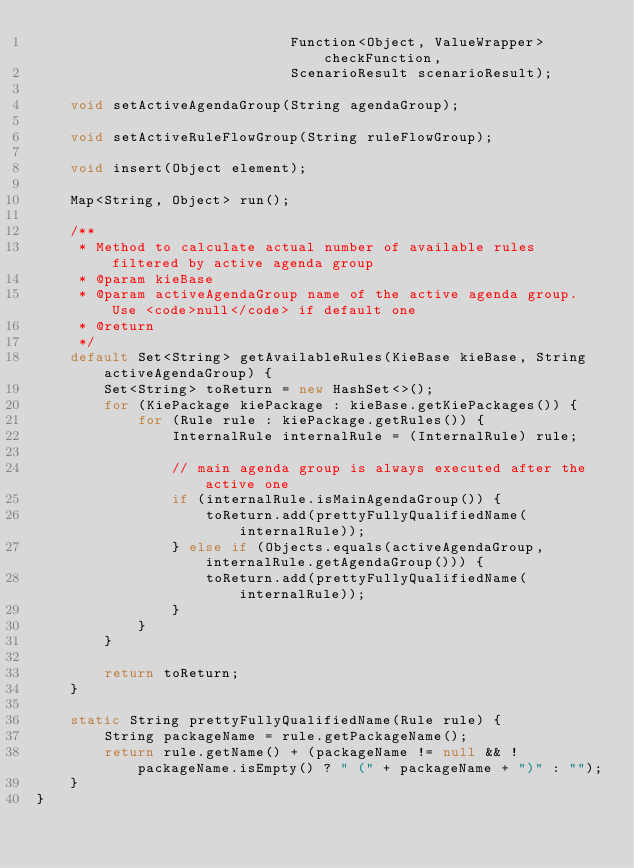Convert code to text. <code><loc_0><loc_0><loc_500><loc_500><_Java_>                              Function<Object, ValueWrapper> checkFunction,
                              ScenarioResult scenarioResult);

    void setActiveAgendaGroup(String agendaGroup);

    void setActiveRuleFlowGroup(String ruleFlowGroup);

    void insert(Object element);

    Map<String, Object> run();

    /**
     * Method to calculate actual number of available rules filtered by active agenda group
     * @param kieBase
     * @param activeAgendaGroup name of the active agenda group. Use <code>null</code> if default one
     * @return
     */
    default Set<String> getAvailableRules(KieBase kieBase, String activeAgendaGroup) {
        Set<String> toReturn = new HashSet<>();
        for (KiePackage kiePackage : kieBase.getKiePackages()) {
            for (Rule rule : kiePackage.getRules()) {
                InternalRule internalRule = (InternalRule) rule;

                // main agenda group is always executed after the active one
                if (internalRule.isMainAgendaGroup()) {
                    toReturn.add(prettyFullyQualifiedName(internalRule));
                } else if (Objects.equals(activeAgendaGroup, internalRule.getAgendaGroup())) {
                    toReturn.add(prettyFullyQualifiedName(internalRule));
                }
            }
        }

        return toReturn;
    }

    static String prettyFullyQualifiedName(Rule rule) {
        String packageName = rule.getPackageName();
        return rule.getName() + (packageName != null && !packageName.isEmpty() ? " (" + packageName + ")" : "");
    }
}
</code> 